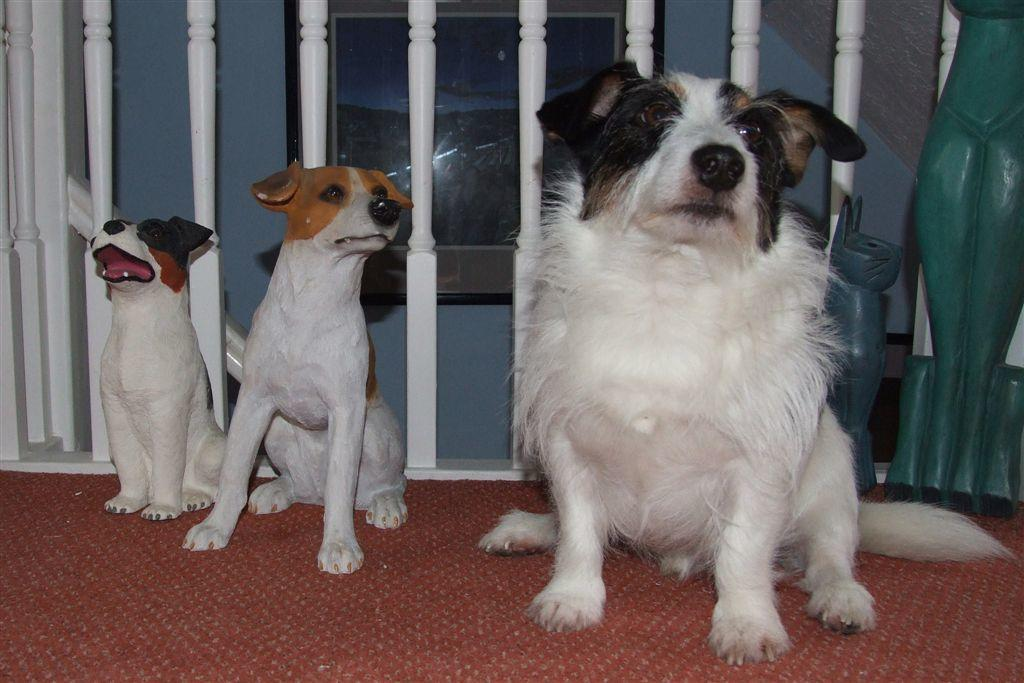What animal is standing on the floor in the image? There is a dog standing on the floor in the image. What can be seen behind the dog in the image? There are statues of dogs behind the dog. What is visible in the background of the image? There is a wall hanging and railings in the background of the image. What type of brush is being used to clean the iron in the image? There is no iron or brush present in the image. 